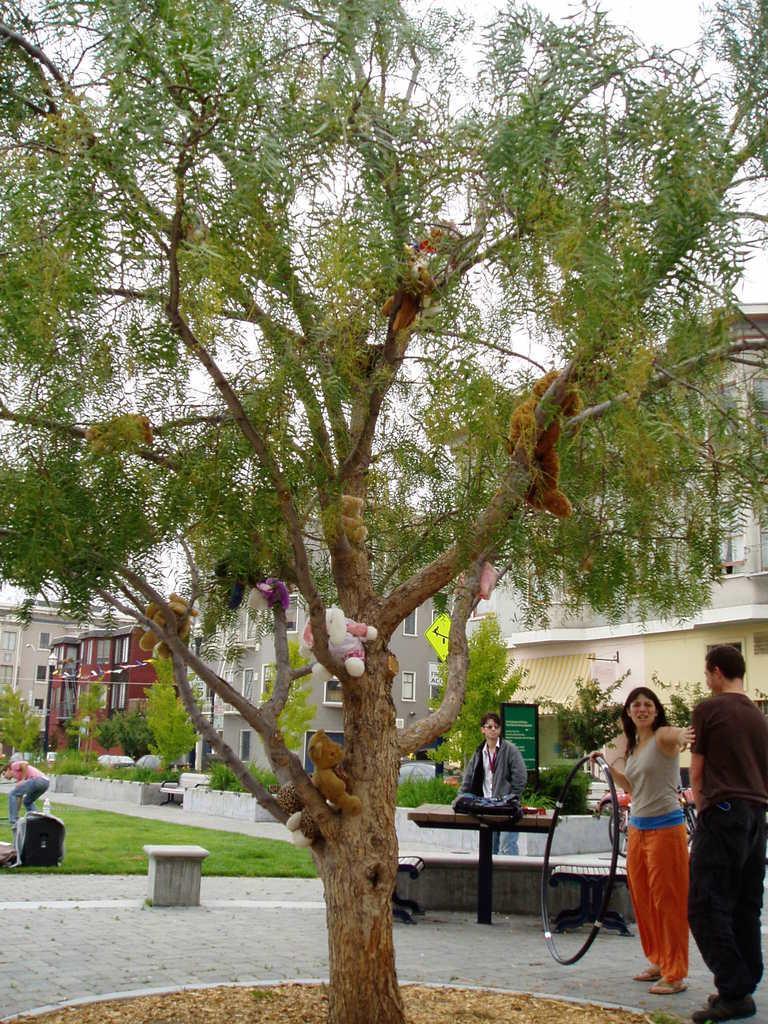In one or two sentences, can you explain what this image depicts? In this image I can see few buildings, windows, grass, few trees, few boards and I can see few people are standing. Here I can see few teddy bears and on this board I can see something is written. 